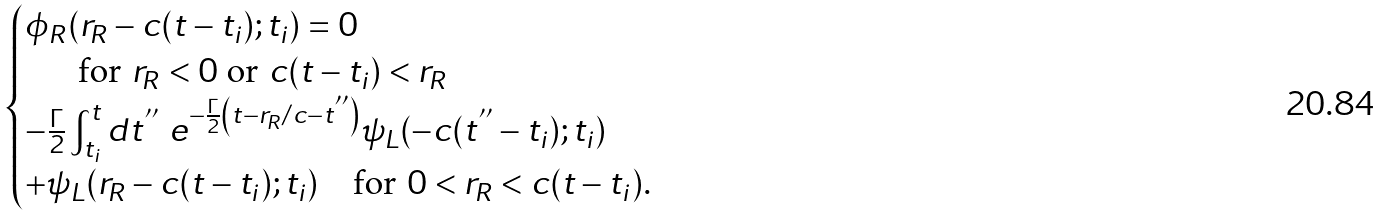Convert formula to latex. <formula><loc_0><loc_0><loc_500><loc_500>\begin{cases} \phi _ { R } ( r _ { R } - c ( t - t _ { i } ) ; t _ { i } ) = 0 \\ \text {\quad \ \ for $r_{R} < 0$ or $c(t-t_{i}) < r_{R}$} \\ - \frac { \Gamma } { 2 } \int ^ { t } _ { t _ { i } } d t ^ { ^ { \prime \prime } } \ e ^ { - \frac { \Gamma } { 2 } \left ( t - r _ { R } / c - t ^ { ^ { \prime \prime } } \right ) } \psi _ { L } ( - c ( t ^ { ^ { \prime \prime } } - t _ { i } ) ; t _ { i } ) \\ + \psi _ { L } ( r _ { R } - c ( t - t _ { i } ) ; t _ { i } ) \text {\quad for $0 < r_{R} < c(t-t_{i})$.} \end{cases}</formula> 